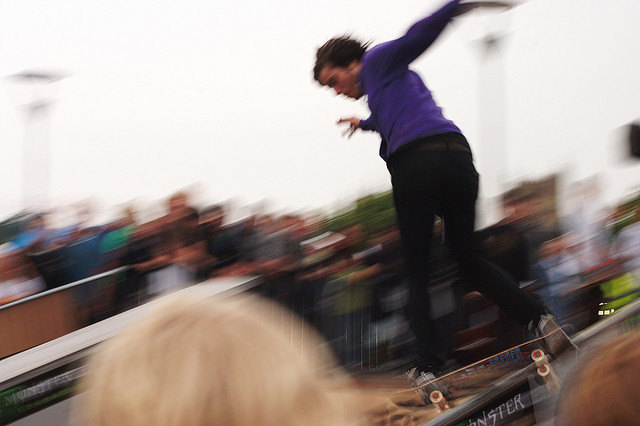<image>What animal is being used in the show? There is no animal being used in the show. What animal is being used in the show? It is unclear what animal is being used in the show. None of the options provided match. 